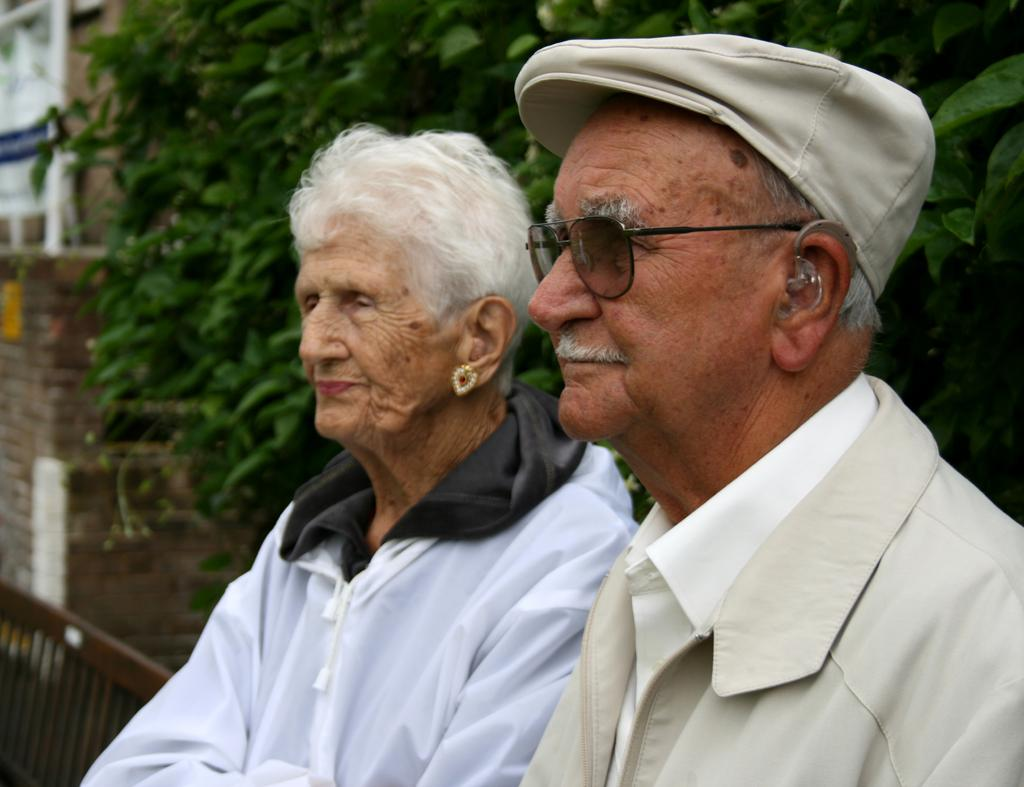How many people are in the image? There are two persons in the center of the image. What can be seen in the background of the image? There are trees, a wall, and a building in the background of the image. What type of yak can be seen in the image? There is no yak present in the image. Can you describe the snake that is slithering around the building in the image? There is no snake present in the image; it only features two persons and background elements. 